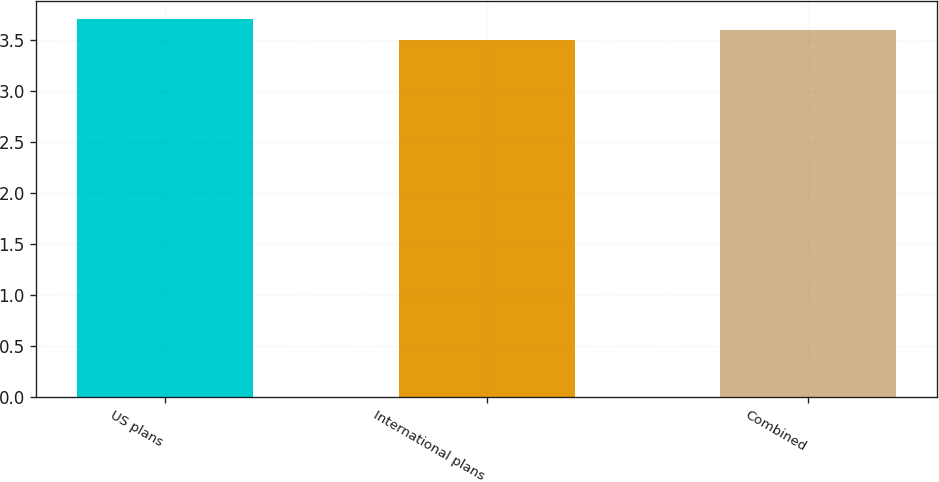Convert chart to OTSL. <chart><loc_0><loc_0><loc_500><loc_500><bar_chart><fcel>US plans<fcel>International plans<fcel>Combined<nl><fcel>3.7<fcel>3.5<fcel>3.6<nl></chart> 